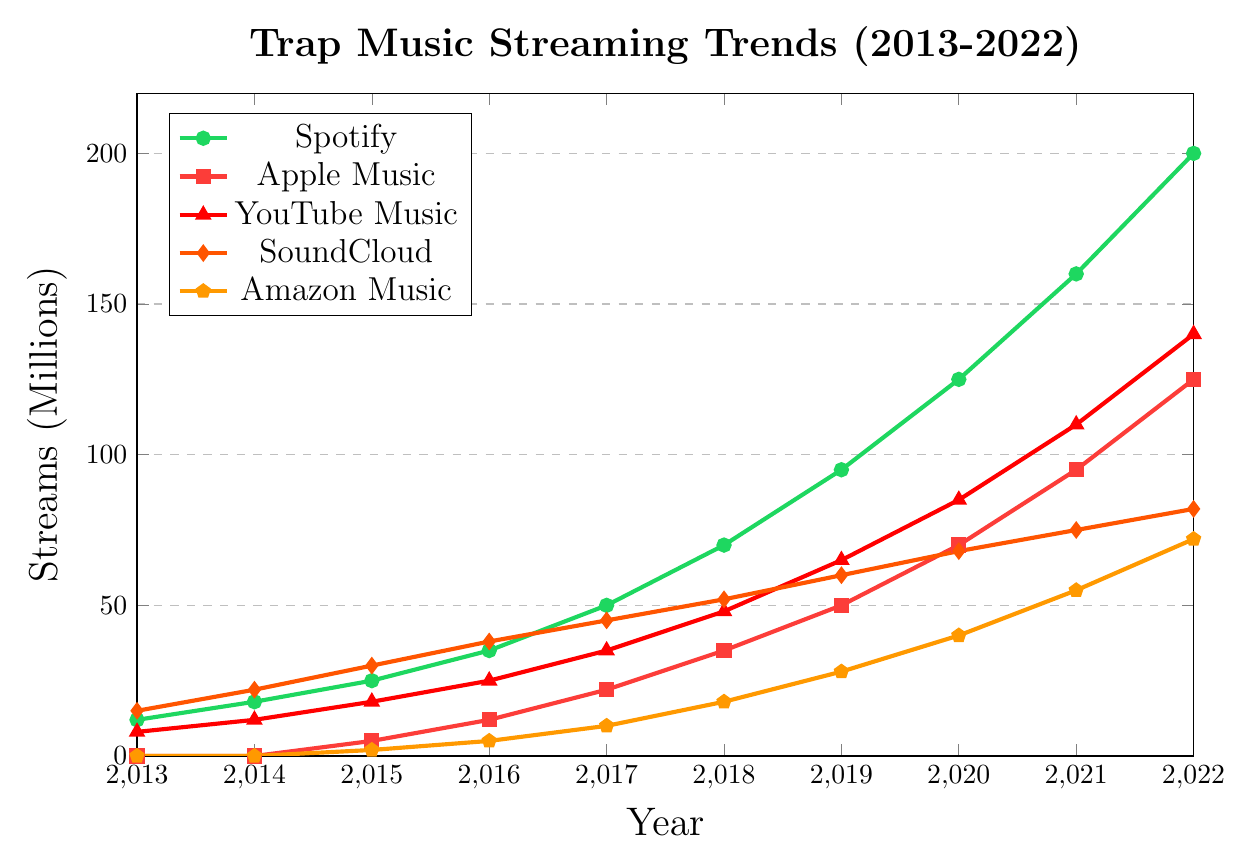What is the trend of Spotify streams from 2013 to 2022? The trend of Spotify streams can be identified by observing the green line that represents Spotify. The line starts at 12 million in 2013 and steadily increases, hitting 200 million by 2022. This shows a positive growth trend over the years.
Answer: Increasing Which streaming platform had the highest number of streams in 2022? To find the platform with the highest number of streams in 2022, look at the endpoints of all the lines on the right side of the graph. The green line, representing Spotify, reaches up to 200 million, higher than any other platform.
Answer: Spotify Which platform showed the most significant increase in streams between 2019 and 2021? To determine this, consider the increase in the number of streams for each platform between 2019 and 2021. For Spotify: 160M (2021) - 95M (2019) = 65M, for Apple Music: 95M (2021) - 50M (2019) = 45M, for YouTube Music: 110M (2021) - 65M (2019) = 45M, for SoundCloud: 75M (2021) - 60M (2019) = 15M, and for Amazon Music: 55M (2021) - 28M (2019) = 27M. Spotify shows the highest increase.
Answer: Spotify How many million more streams did Apple Music have compared to SoundCloud in 2022? To find this, subtract SoundCloud's streams from Apple Music's streams in 2022. For Apple Music, it is 125M, while for SoundCloud, it is 82M. The difference is 125M - 82M = 43M.
Answer: 43M Between which years did YouTube Music have the highest growth? To find the period of highest growth for YouTube Music, look at the slope of the red line representing YouTube Music. Calculating the yearly increments: 2016-2017: 10M, 2017-2018: 13M, 2018-2019: 17M, 2019-2020: 20M, 2020-2021: 25M, 2021-2022: 30M. The highest growth is between 2021 and 2022.
Answer: 2021-2022 Which platform had the smallest increase in streams between 2013 and 2017? To determine this, calculate the increase for each platform over this period. Spotify: 50M - 12M = 38M, Apple Music: 22M - 0M = 22M, YouTube Music: 35M - 8M = 27M, SoundCloud: 45M - 15M = 30M, Amazon Music: 10M - 0M = 10M. Amazon Music had the smallest increase.
Answer: Amazon Music In what year did Apple Music first reach more than 50 million streams? By looking at the Apple Music trend line, it crosses 50 million at the transition from 2018 to 2019.
Answer: 2019 How does the growth of SoundCloud streams compare to Amazon Music streams from 2015 to 2022? SoundCloud's streams go from 30M in 2015 to 82M in 2022, an increase of 52M. Amazon Music grows from 2M in 2015 to 72M in 2022, an increase of 70M. Although Amazon Music starts lower, its growth is higher than SoundCloud over these years.
Answer: Amazon Music grows faster 